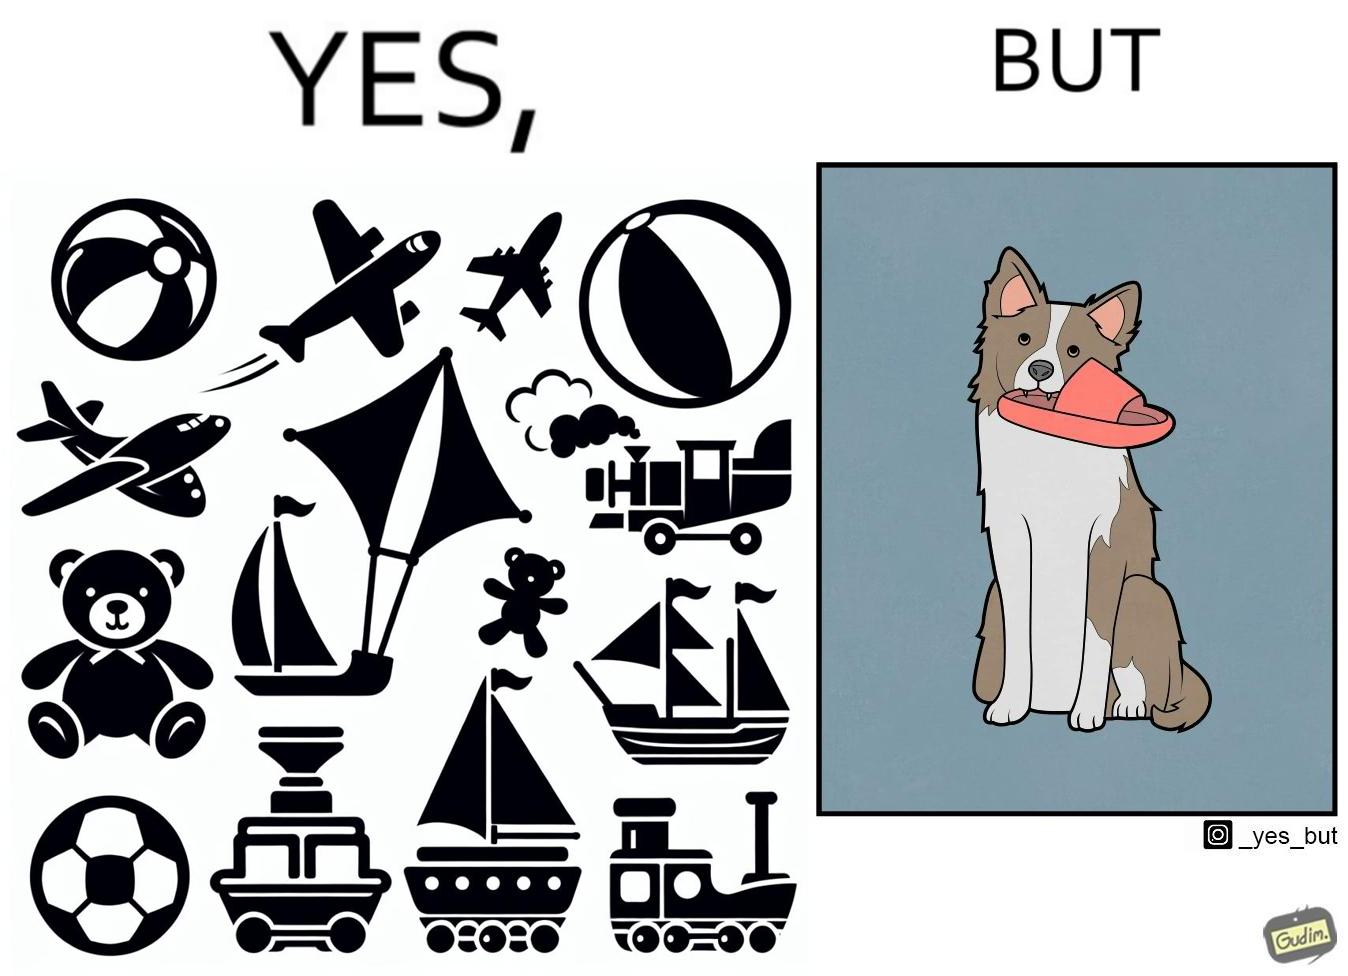Is this a satirical image? Yes, this image is satirical. 